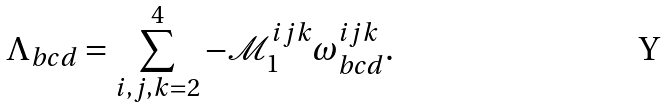Convert formula to latex. <formula><loc_0><loc_0><loc_500><loc_500>\Lambda _ { b c d } = \sum _ { i , j , k = 2 } ^ { 4 } - \mathcal { M } ^ { i j k } _ { 1 } \omega ^ { i j k } _ { b c d } .</formula> 